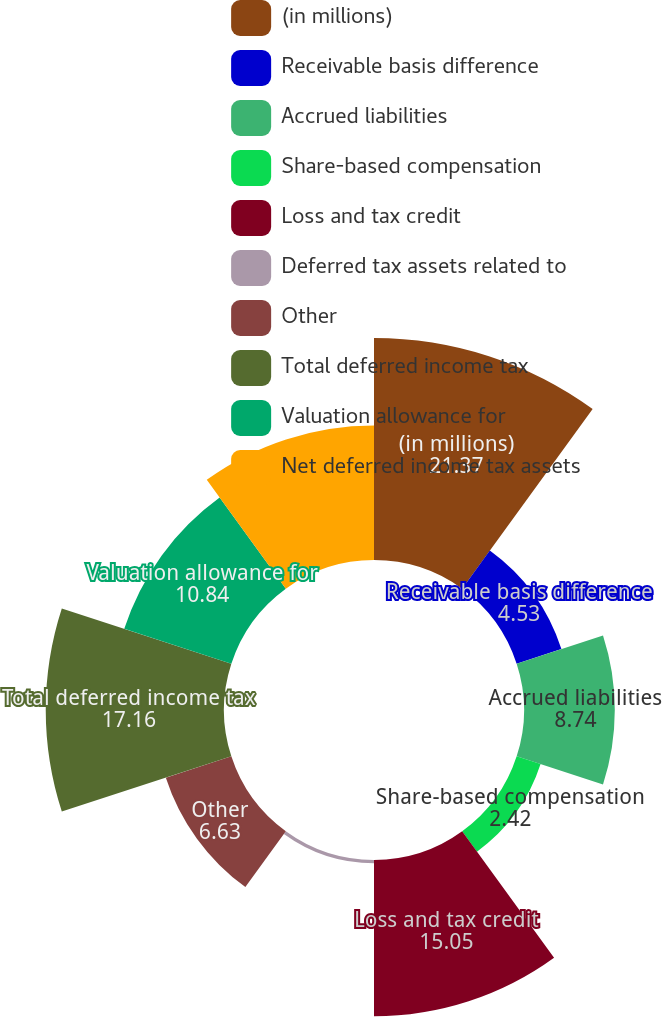Convert chart to OTSL. <chart><loc_0><loc_0><loc_500><loc_500><pie_chart><fcel>(in millions)<fcel>Receivable basis difference<fcel>Accrued liabilities<fcel>Share-based compensation<fcel>Loss and tax credit<fcel>Deferred tax assets related to<fcel>Other<fcel>Total deferred income tax<fcel>Valuation allowance for<fcel>Net deferred income tax assets<nl><fcel>21.37%<fcel>4.53%<fcel>8.74%<fcel>2.42%<fcel>15.05%<fcel>0.32%<fcel>6.63%<fcel>17.16%<fcel>10.84%<fcel>12.95%<nl></chart> 